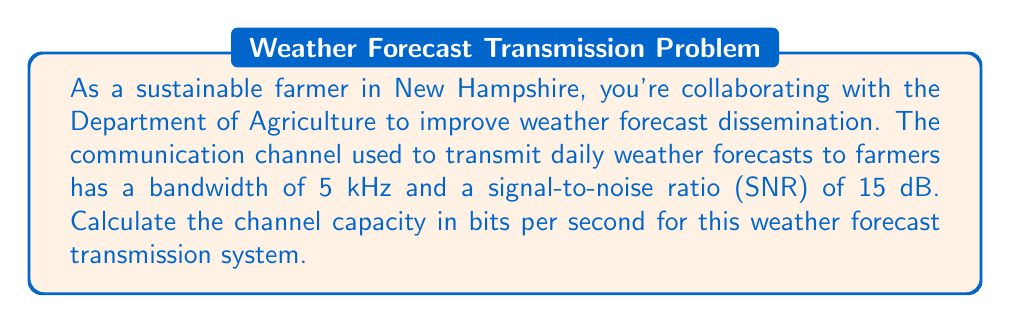Solve this math problem. To solve this problem, we'll use the Shannon-Hartley theorem, which gives the channel capacity for a communication channel with additive white Gaussian noise. The formula is:

$$C = B \log_2(1 + SNR)$$

Where:
$C$ = Channel capacity (bits per second)
$B$ = Bandwidth (Hz)
$SNR$ = Signal-to-Noise Ratio (linear scale)

Given:
- Bandwidth ($B$) = 5 kHz = 5000 Hz
- SNR = 15 dB

Step 1: Convert SNR from decibels to linear scale
$SNR_{linear} = 10^{(SNR_{dB}/10)} = 10^{(15/10)} = 10^{1.5} \approx 31.6228$

Step 2: Apply the Shannon-Hartley theorem
$$\begin{align*}
C &= B \log_2(1 + SNR) \\
&= 5000 \log_2(1 + 31.6228) \\
&= 5000 \log_2(32.6228)
\end{align*}$$

Step 3: Calculate the result
$$\begin{align*}
C &= 5000 \times 5.0279 \\
&= 25,139.5 \text{ bits per second}
\end{align*}$$

Therefore, the channel capacity for transmitting weather forecasts to farmers is approximately 25,139.5 bits per second.
Answer: $C \approx 25,139.5 \text{ bits per second}$ 